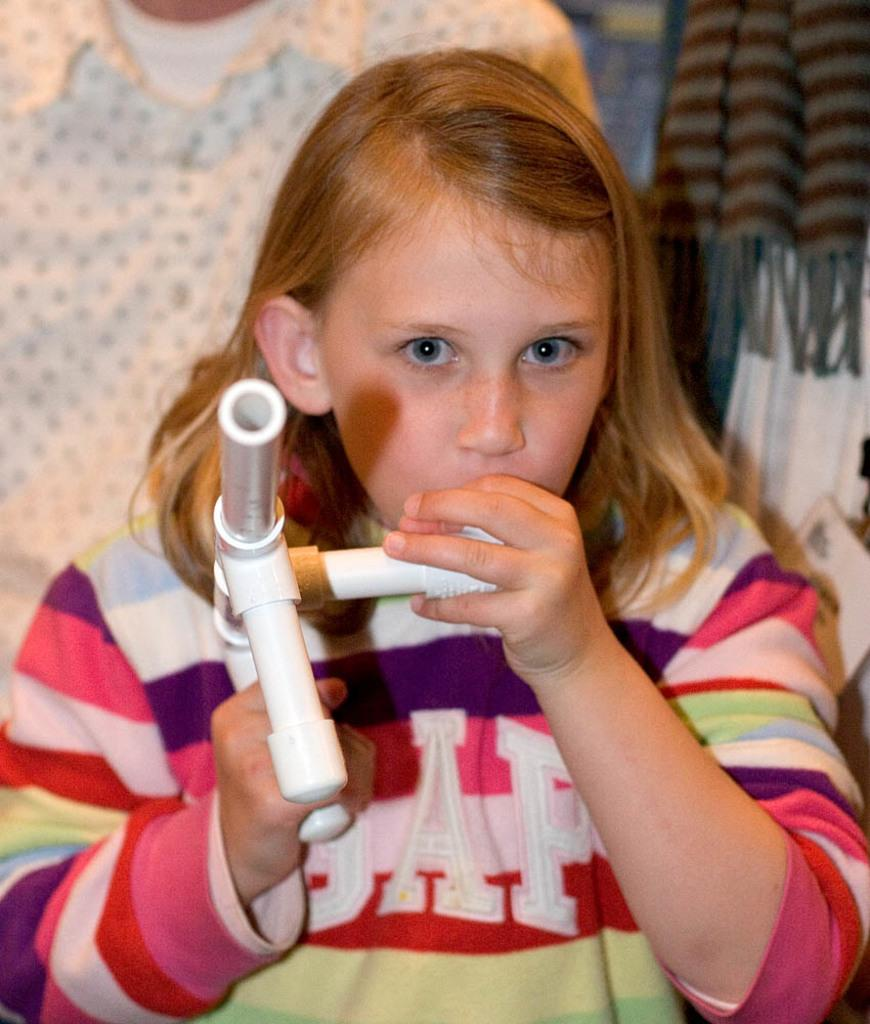Who is the main subject in the image? There is a girl in the image. What is the girl holding in the image? The girl is holding an object. Can you describe the girl's clothing in the image? The girl is wearing a striped t-shirt. Is there anyone else visible in the image? Yes, there is a person in the background of the image. How is the person in the background dressed? The person in the background is wearing a white shirt. What type of train can be seen in the image? There is no train present in the image. What is the girl using to carry her belongings in the image? The girl is holding an object, but it is not specified as a tray or locket in the provided facts. 